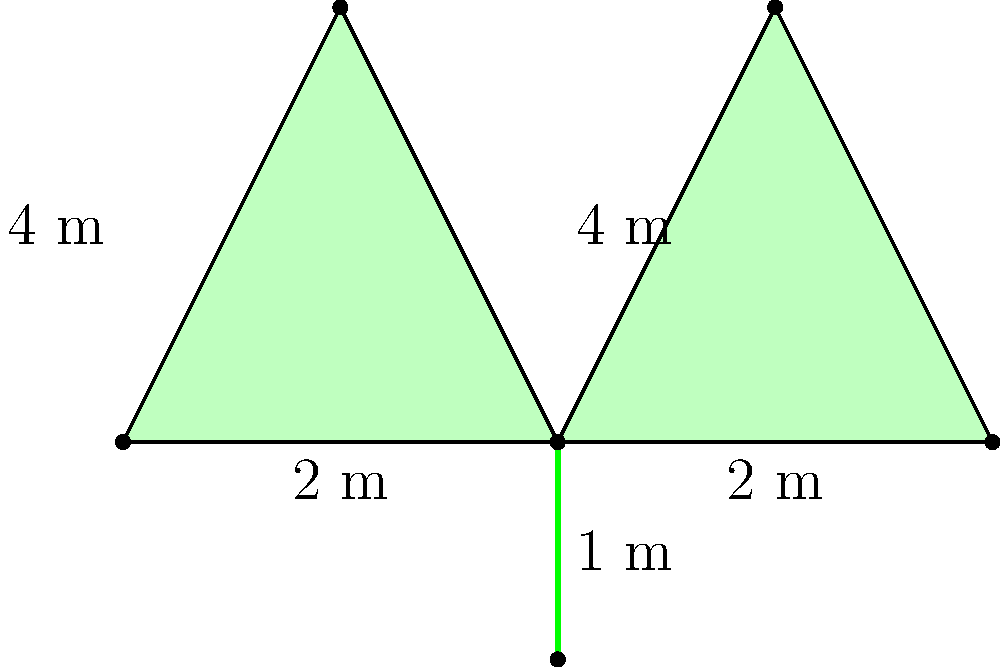In honor of Scotland's national flower, you've designed a thistle-shaped garden plot for your writing retreat. The plot consists of four equilateral triangles forming the thistle's head and a rectangle for the stem, as shown in the diagram. If each side of the triangles measures 2 meters and the stem is 1 meter long and 2 meters wide, what is the total area of your thistle-shaped garden plot in square meters? Let's approach this step-by-step:

1. Calculate the area of one equilateral triangle:
   - The formula for the area of an equilateral triangle is $A = \frac{\sqrt{3}}{4}a^2$, where $a$ is the side length.
   - With $a = 2$ meters, we get: $A = \frac{\sqrt{3}}{4}(2^2) = \sqrt{3}$ m²

2. Calculate the total area of the four triangles:
   - Total triangle area = $4 \times \sqrt{3}$ m² = $4\sqrt{3}$ m²

3. Calculate the area of the rectangular stem:
   - Area of rectangle = length × width
   - Area of stem = $1$ m × $2$ m = $2$ m²

4. Sum up the total area:
   - Total area = Area of triangles + Area of stem
   - Total area = $4\sqrt{3}$ m² + $2$ m²
   - Total area = $4\sqrt{3} + 2$ m²

5. Simplify the expression:
   - $4\sqrt{3} + 2 \approx 8.93$ m² (rounded to two decimal places)

Therefore, the total area of your thistle-shaped garden plot is $4\sqrt{3} + 2$ square meters or approximately 8.93 square meters.
Answer: $4\sqrt{3} + 2$ m² 